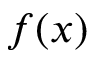<formula> <loc_0><loc_0><loc_500><loc_500>f ( x )</formula> 